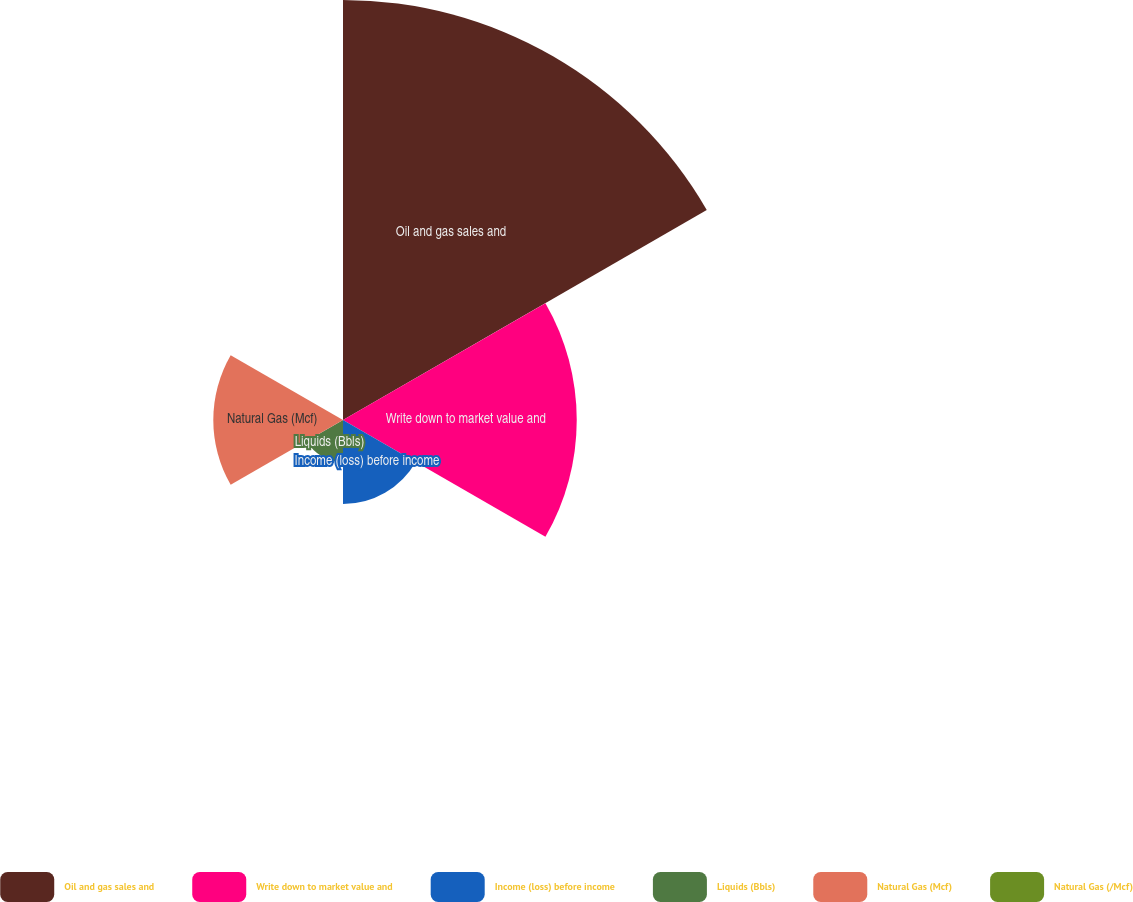Convert chart. <chart><loc_0><loc_0><loc_500><loc_500><pie_chart><fcel>Oil and gas sales and<fcel>Write down to market value and<fcel>Income (loss) before income<fcel>Liquids (Bbls)<fcel>Natural Gas (Mcf)<fcel>Natural Gas (/Mcf)<nl><fcel>46.18%<fcel>25.7%<fcel>9.24%<fcel>4.62%<fcel>14.26%<fcel>0.0%<nl></chart> 